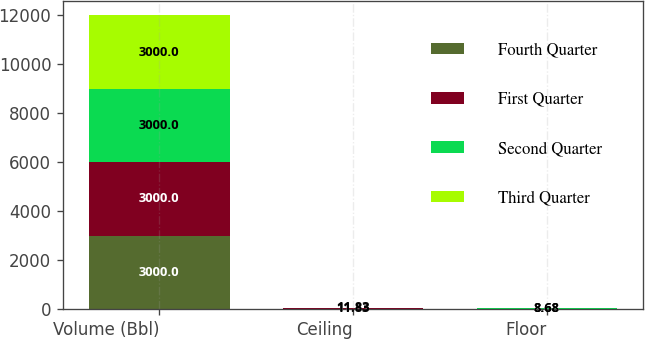<chart> <loc_0><loc_0><loc_500><loc_500><stacked_bar_chart><ecel><fcel>Volume (Bbl)<fcel>Ceiling<fcel>Floor<nl><fcel>Fourth Quarter<fcel>3000<fcel>11.83<fcel>8.68<nl><fcel>First Quarter<fcel>3000<fcel>11.83<fcel>8.68<nl><fcel>Second Quarter<fcel>3000<fcel>11.83<fcel>8.68<nl><fcel>Third Quarter<fcel>3000<fcel>11.83<fcel>8.68<nl></chart> 